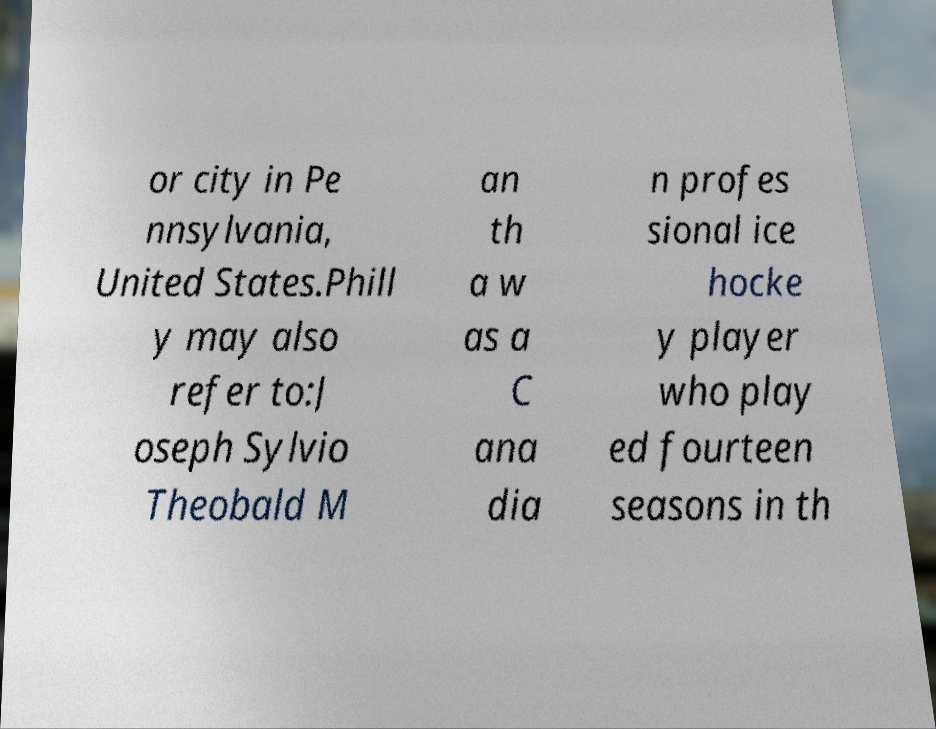Can you accurately transcribe the text from the provided image for me? or city in Pe nnsylvania, United States.Phill y may also refer to:J oseph Sylvio Theobald M an th a w as a C ana dia n profes sional ice hocke y player who play ed fourteen seasons in th 